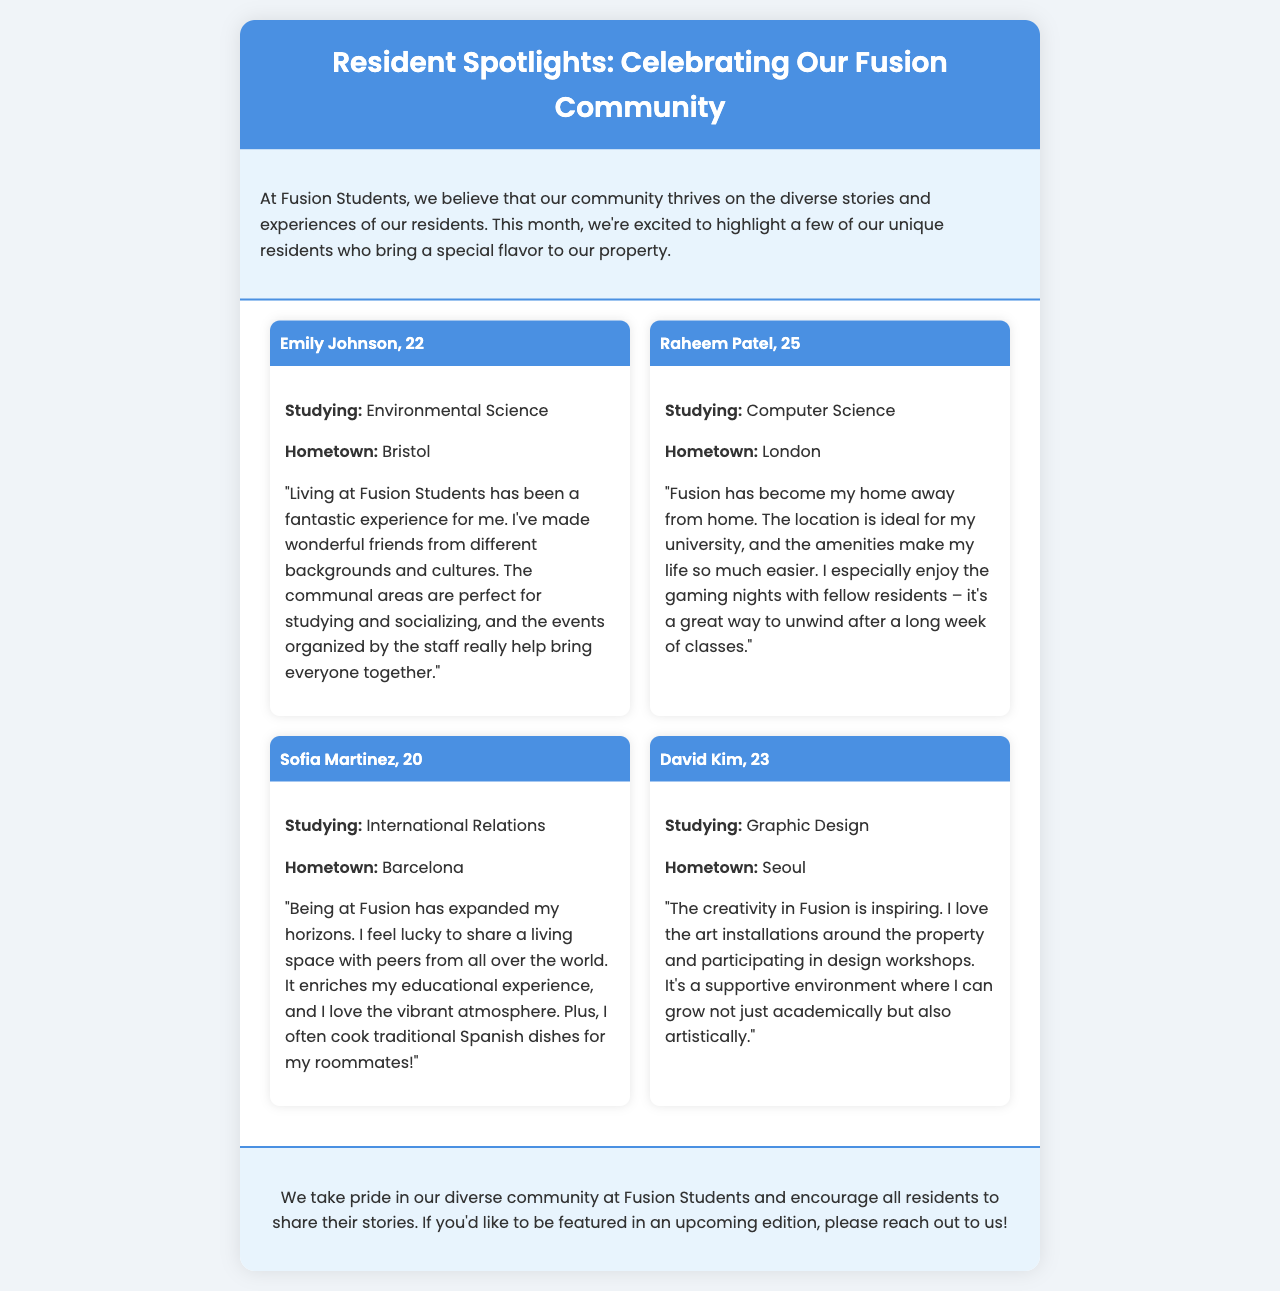What is the title of the newsletter? The title of the newsletter is presented prominently in the header section of the document.
Answer: Resident Spotlights: Celebrating Our Fusion Community Who is studying Environmental Science? The document provides a specific spotlight on residents, including their studies and backgrounds.
Answer: Emily Johnson How old is Raheem Patel? The age of Raheem Patel is included in the profile section of the document.
Answer: 25 What is Sofia Martinez's hometown? The hometown of Sofia Martinez is mentioned in her spotlight profile.
Answer: Barcelona What has David Kim found inspiring at Fusion? The document mentions specific aspects that residents appreciate about living at Fusion.
Answer: Creativity Which resident enjoys gaming nights? The profile section indicates particular activities that residents enjoy.
Answer: Raheem Patel What type of dishes does Sofia cook for her roommates? The spotlight profiles include personal touches about the residents' experiences and activities.
Answer: Traditional Spanish dishes What is emphasized at the conclusion of the newsletter? The conclusion summarizes the overall theme and encourages participation from residents.
Answer: Diverse community How many spotlights are featured in the newsletter? The document lists the number of individual resident spotlights included.
Answer: Four 